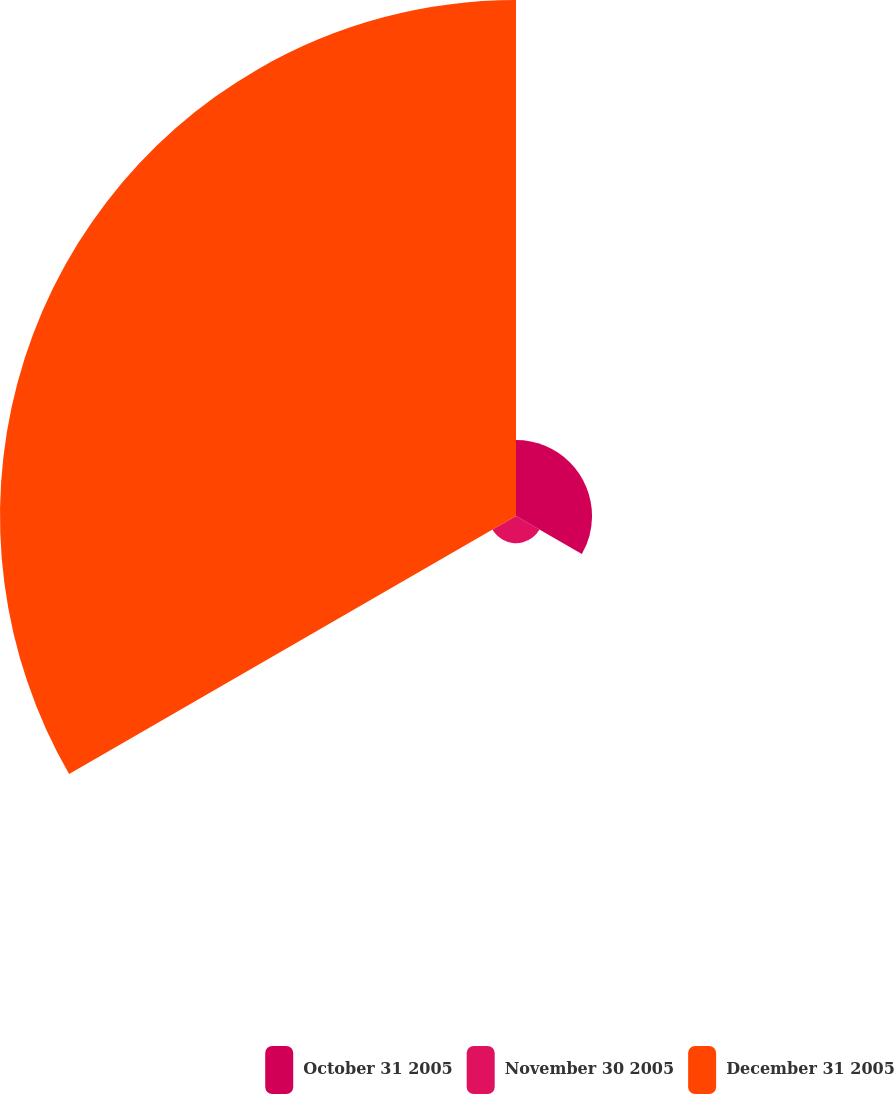Convert chart to OTSL. <chart><loc_0><loc_0><loc_500><loc_500><pie_chart><fcel>October 31 2005<fcel>November 30 2005<fcel>December 31 2005<nl><fcel>12.28%<fcel>4.39%<fcel>83.33%<nl></chart> 